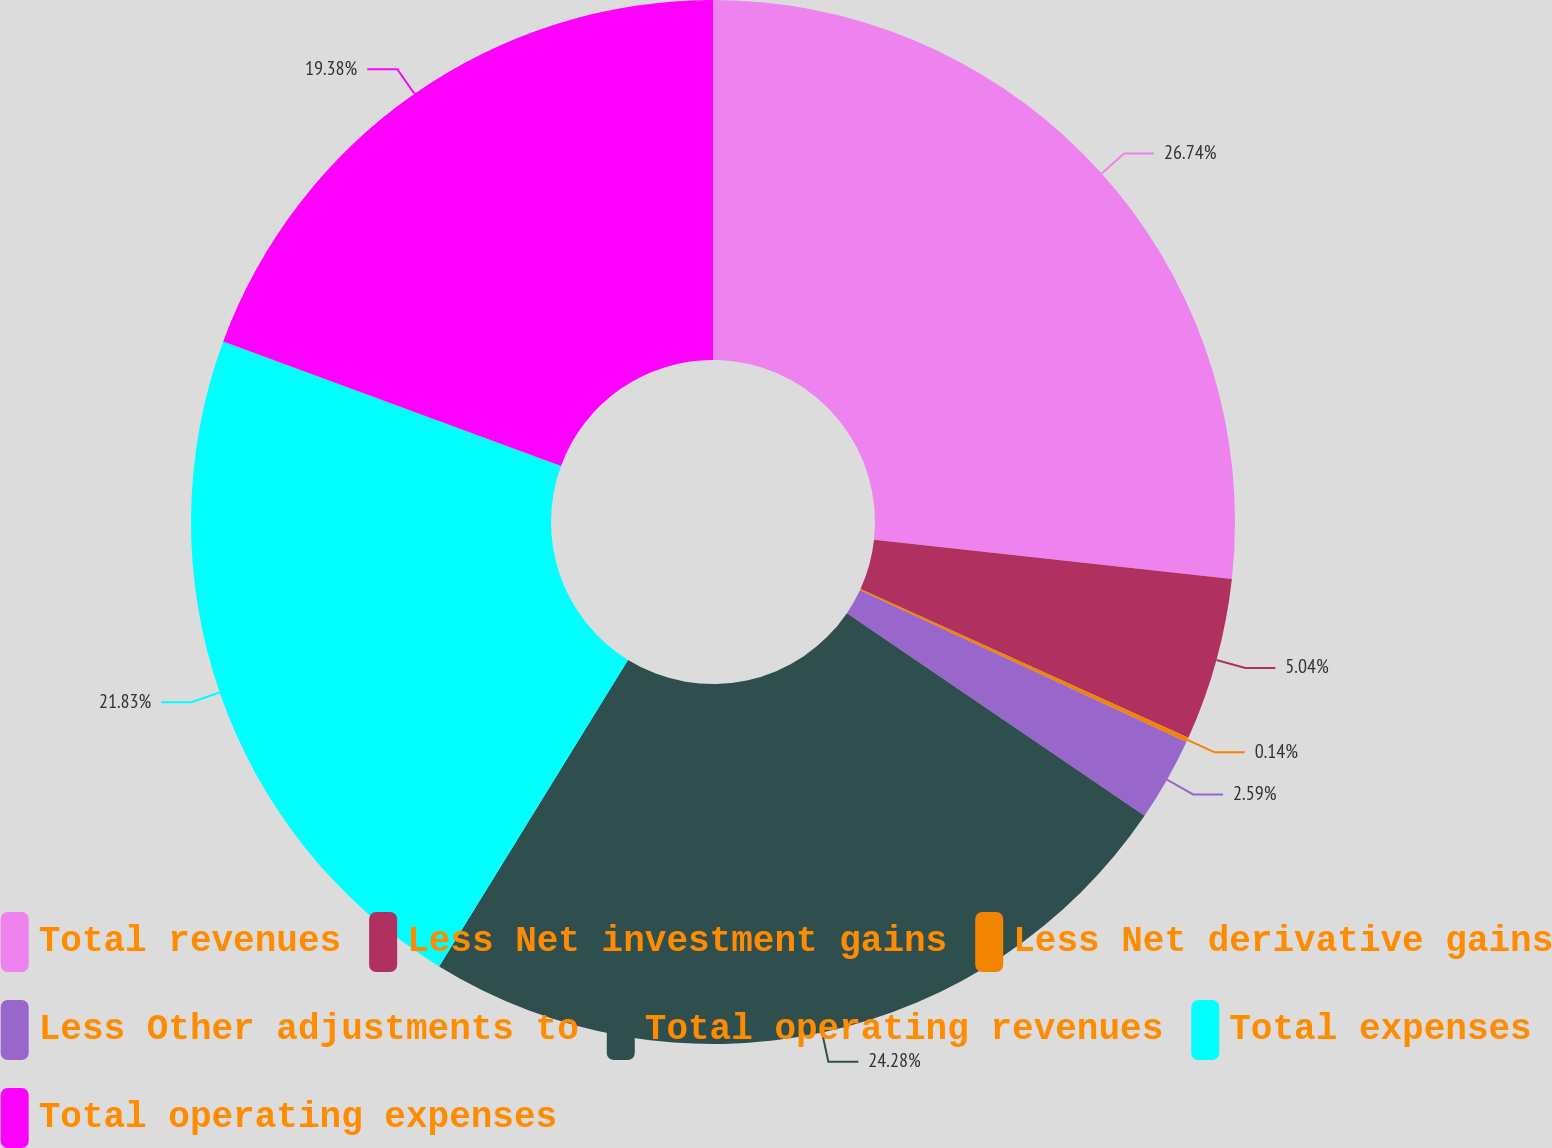Convert chart to OTSL. <chart><loc_0><loc_0><loc_500><loc_500><pie_chart><fcel>Total revenues<fcel>Less Net investment gains<fcel>Less Net derivative gains<fcel>Less Other adjustments to<fcel>Total operating revenues<fcel>Total expenses<fcel>Total operating expenses<nl><fcel>26.74%<fcel>5.04%<fcel>0.14%<fcel>2.59%<fcel>24.28%<fcel>21.83%<fcel>19.38%<nl></chart> 